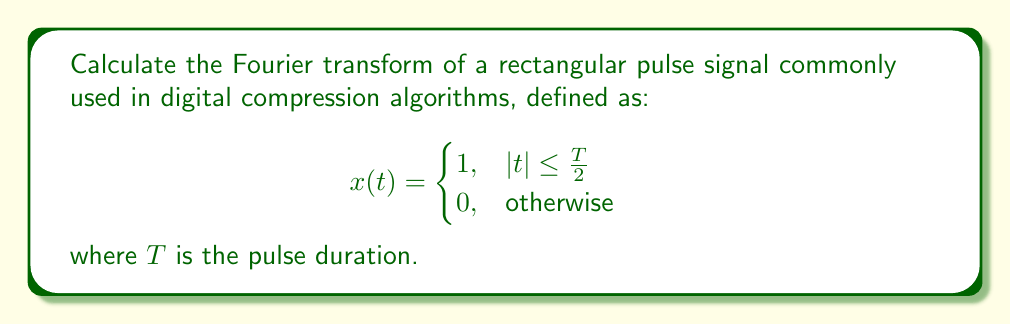Can you answer this question? To compute the Fourier transform of this rectangular pulse signal, we'll follow these steps:

1) The Fourier transform is defined as:
   $$X(f) = \int_{-\infty}^{\infty} x(t) e^{-j2\pi ft} dt$$

2) Given the signal definition, we can rewrite the integral as:
   $$X(f) = \int_{-T/2}^{T/2} 1 \cdot e^{-j2\pi ft} dt$$

3) Evaluate the integral:
   $$X(f) = \left[-\frac{1}{j2\pi f} e^{-j2\pi ft}\right]_{-T/2}^{T/2}$$

4) Substitute the limits:
   $$X(f) = -\frac{1}{j2\pi f} \left(e^{-j\pi fT} - e^{j\pi fT}\right)$$

5) Simplify using Euler's formula ($e^{jx} - e^{-jx} = 2j\sin(x)$):
   $$X(f) = -\frac{1}{j2\pi f} (-2j\sin(\pi fT))$$

6) Simplify further:
   $$X(f) = \frac{\sin(\pi fT)}{\pi f}$$

7) Recognize that this can be written as:
   $$X(f) = T \cdot \text{sinc}(\pi fT)$$

Where $\text{sinc}(x) = \frac{\sin(x)}{x}$ is the normalized sinc function.

This result, known as the sinc function, is crucial in digital signal processing and compression algorithms due to its frequency-domain characteristics.
Answer: $X(f) = T \cdot \text{sinc}(\pi fT)$ 